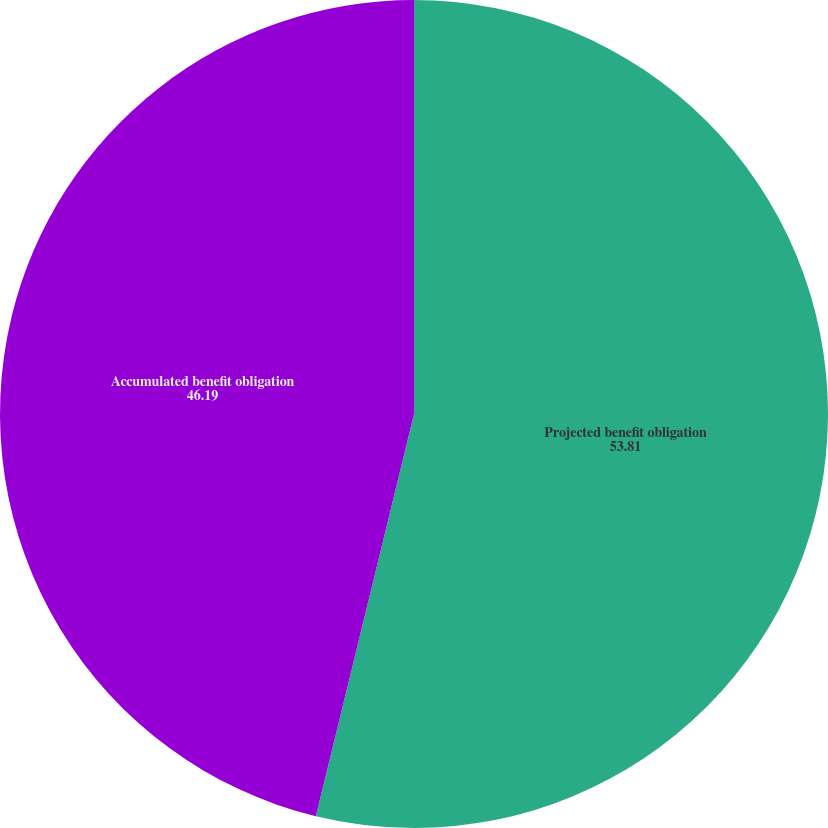<chart> <loc_0><loc_0><loc_500><loc_500><pie_chart><fcel>Projected benefit obligation<fcel>Accumulated benefit obligation<nl><fcel>53.81%<fcel>46.19%<nl></chart> 